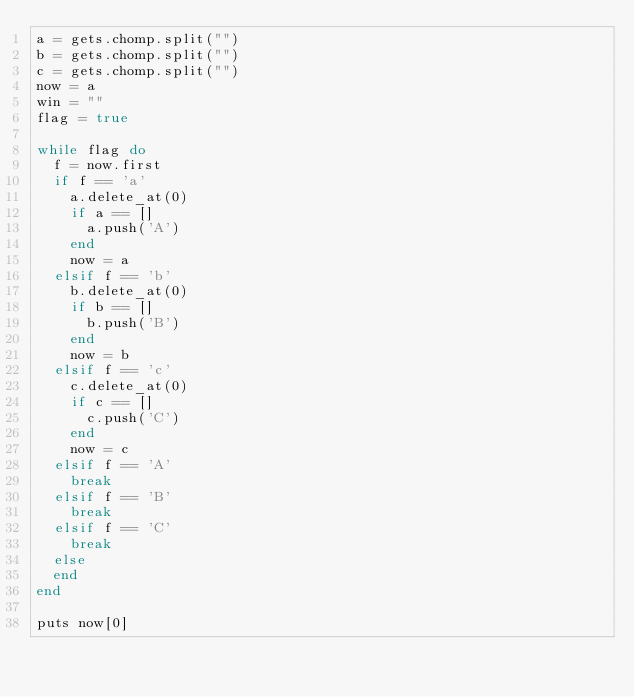Convert code to text. <code><loc_0><loc_0><loc_500><loc_500><_Ruby_>a = gets.chomp.split("")
b = gets.chomp.split("")
c = gets.chomp.split("")
now = a
win = ""
flag = true

while flag do
  f = now.first
  if f == 'a' 
    a.delete_at(0)
    if a == []
      a.push('A')
    end
    now = a
  elsif f == 'b'
    b.delete_at(0)
    if b == []
      b.push('B')
    end
    now = b
  elsif f == 'c'
    c.delete_at(0)
    if c == []
      c.push('C')
    end
    now = c
  elsif f == 'A'
    break
  elsif f == 'B'
    break
  elsif f == 'C'
    break
  else
  end
end

puts now[0]</code> 